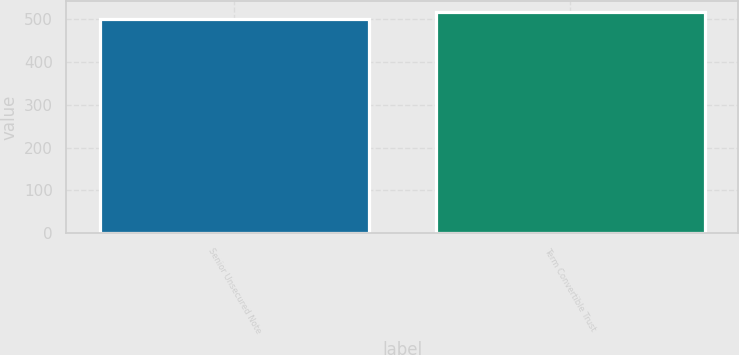Convert chart. <chart><loc_0><loc_0><loc_500><loc_500><bar_chart><fcel>Senior Unsecured Note<fcel>Term Convertible Trust<nl><fcel>500<fcel>517<nl></chart> 